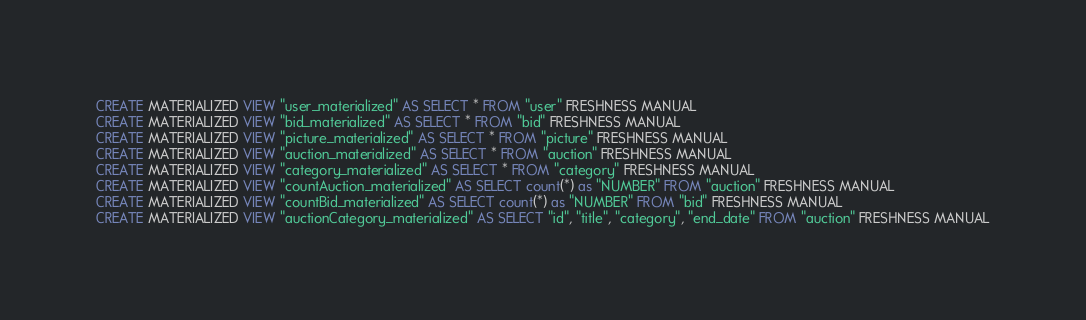<code> <loc_0><loc_0><loc_500><loc_500><_SQL_>CREATE MATERIALIZED VIEW "user_materialized" AS SELECT * FROM "user" FRESHNESS MANUAL
CREATE MATERIALIZED VIEW "bid_materialized" AS SELECT * FROM "bid" FRESHNESS MANUAL
CREATE MATERIALIZED VIEW "picture_materialized" AS SELECT * FROM "picture" FRESHNESS MANUAL
CREATE MATERIALIZED VIEW "auction_materialized" AS SELECT * FROM "auction" FRESHNESS MANUAL
CREATE MATERIALIZED VIEW "category_materialized" AS SELECT * FROM "category" FRESHNESS MANUAL
CREATE MATERIALIZED VIEW "countAuction_materialized" AS SELECT count(*) as "NUMBER" FROM "auction" FRESHNESS MANUAL
CREATE MATERIALIZED VIEW "countBid_materialized" AS SELECT count(*) as "NUMBER" FROM "bid" FRESHNESS MANUAL
CREATE MATERIALIZED VIEW "auctionCategory_materialized" AS SELECT "id", "title", "category", "end_date" FROM "auction" FRESHNESS MANUAL</code> 